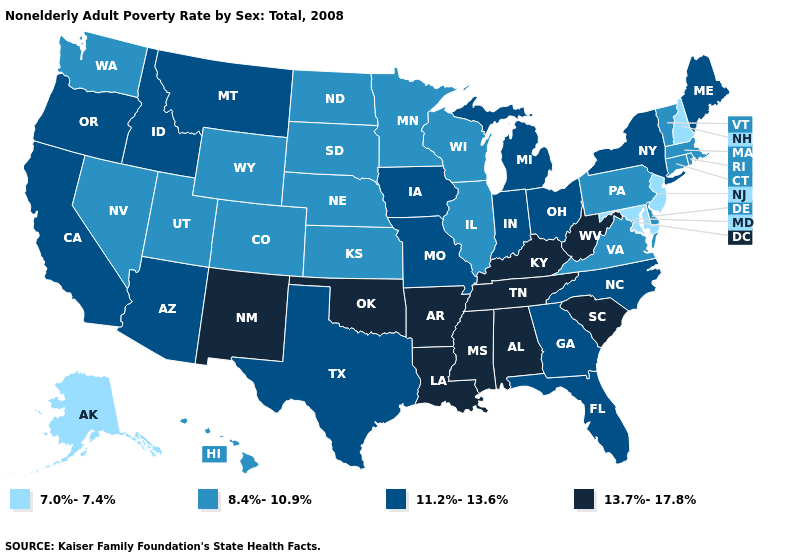Among the states that border Rhode Island , which have the lowest value?
Write a very short answer. Connecticut, Massachusetts. Does Maine have the highest value in the Northeast?
Answer briefly. Yes. Name the states that have a value in the range 11.2%-13.6%?
Answer briefly. Arizona, California, Florida, Georgia, Idaho, Indiana, Iowa, Maine, Michigan, Missouri, Montana, New York, North Carolina, Ohio, Oregon, Texas. Does the map have missing data?
Be succinct. No. Does Maryland have the same value as Rhode Island?
Short answer required. No. Name the states that have a value in the range 8.4%-10.9%?
Give a very brief answer. Colorado, Connecticut, Delaware, Hawaii, Illinois, Kansas, Massachusetts, Minnesota, Nebraska, Nevada, North Dakota, Pennsylvania, Rhode Island, South Dakota, Utah, Vermont, Virginia, Washington, Wisconsin, Wyoming. Name the states that have a value in the range 13.7%-17.8%?
Quick response, please. Alabama, Arkansas, Kentucky, Louisiana, Mississippi, New Mexico, Oklahoma, South Carolina, Tennessee, West Virginia. Name the states that have a value in the range 7.0%-7.4%?
Short answer required. Alaska, Maryland, New Hampshire, New Jersey. Which states have the lowest value in the Northeast?
Give a very brief answer. New Hampshire, New Jersey. Name the states that have a value in the range 7.0%-7.4%?
Short answer required. Alaska, Maryland, New Hampshire, New Jersey. What is the value of Louisiana?
Quick response, please. 13.7%-17.8%. What is the value of Idaho?
Be succinct. 11.2%-13.6%. What is the lowest value in the South?
Concise answer only. 7.0%-7.4%. Name the states that have a value in the range 8.4%-10.9%?
Keep it brief. Colorado, Connecticut, Delaware, Hawaii, Illinois, Kansas, Massachusetts, Minnesota, Nebraska, Nevada, North Dakota, Pennsylvania, Rhode Island, South Dakota, Utah, Vermont, Virginia, Washington, Wisconsin, Wyoming. Does Tennessee have the highest value in the USA?
Write a very short answer. Yes. 